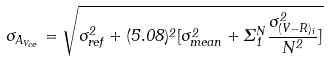<formula> <loc_0><loc_0><loc_500><loc_500>\sigma _ { A _ { V _ { c e } } } = \sqrt { \sigma _ { r e f } ^ { 2 } + ( 5 . 0 8 ) ^ { 2 } [ \sigma ^ { 2 } _ { m e a n } + \Sigma _ { 1 } ^ { N } \frac { \sigma ^ { 2 } _ { ( V - R ) _ { i } } } { N ^ { 2 } } ] }</formula> 